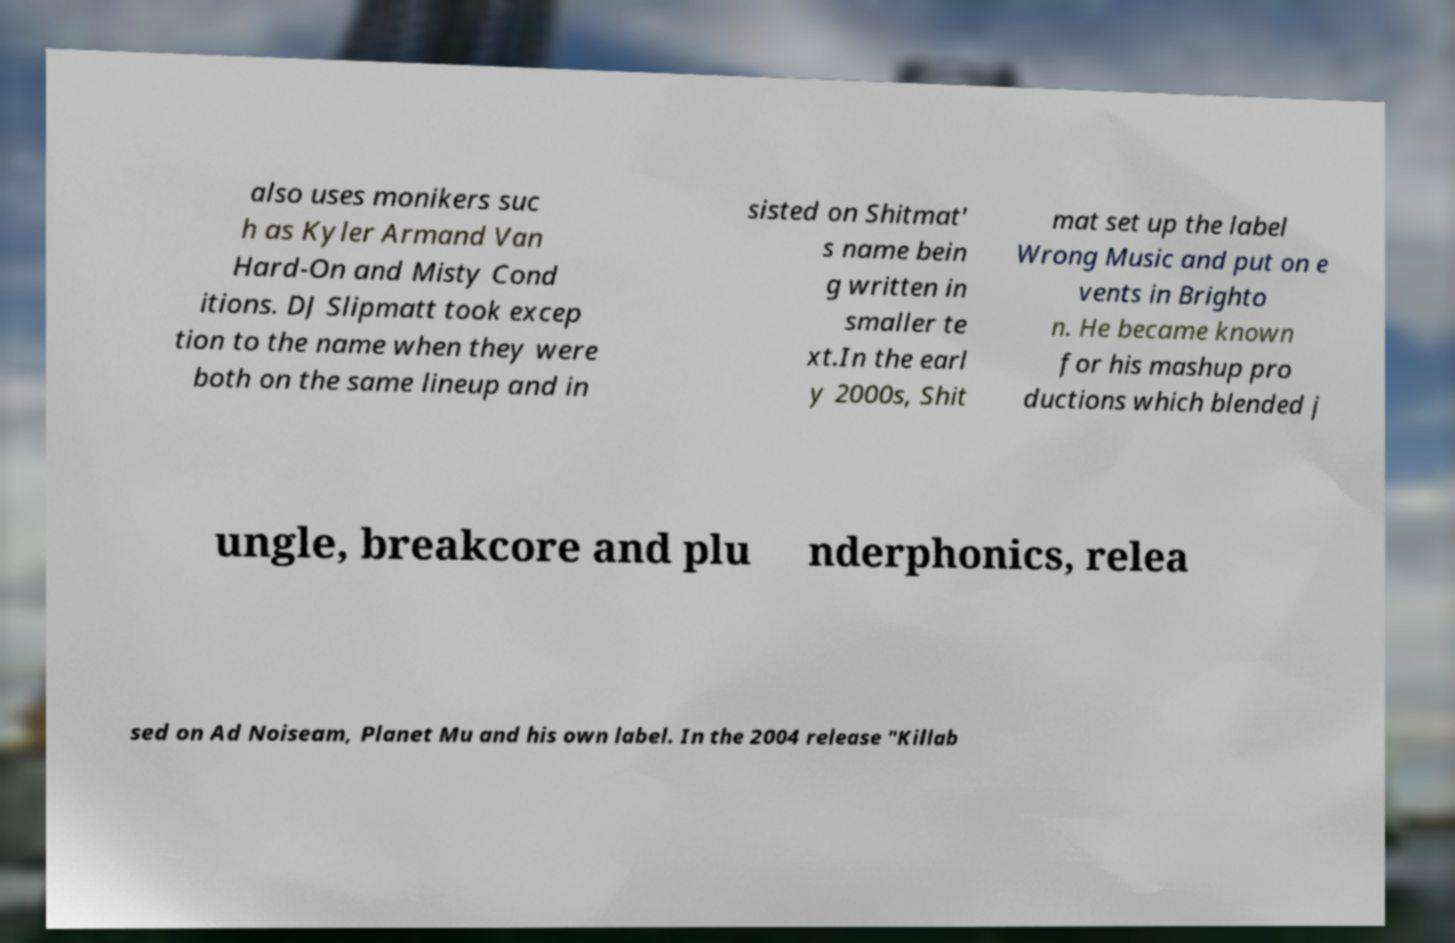Please read and relay the text visible in this image. What does it say? also uses monikers suc h as Kyler Armand Van Hard-On and Misty Cond itions. DJ Slipmatt took excep tion to the name when they were both on the same lineup and in sisted on Shitmat' s name bein g written in smaller te xt.In the earl y 2000s, Shit mat set up the label Wrong Music and put on e vents in Brighto n. He became known for his mashup pro ductions which blended j ungle, breakcore and plu nderphonics, relea sed on Ad Noiseam, Planet Mu and his own label. In the 2004 release "Killab 